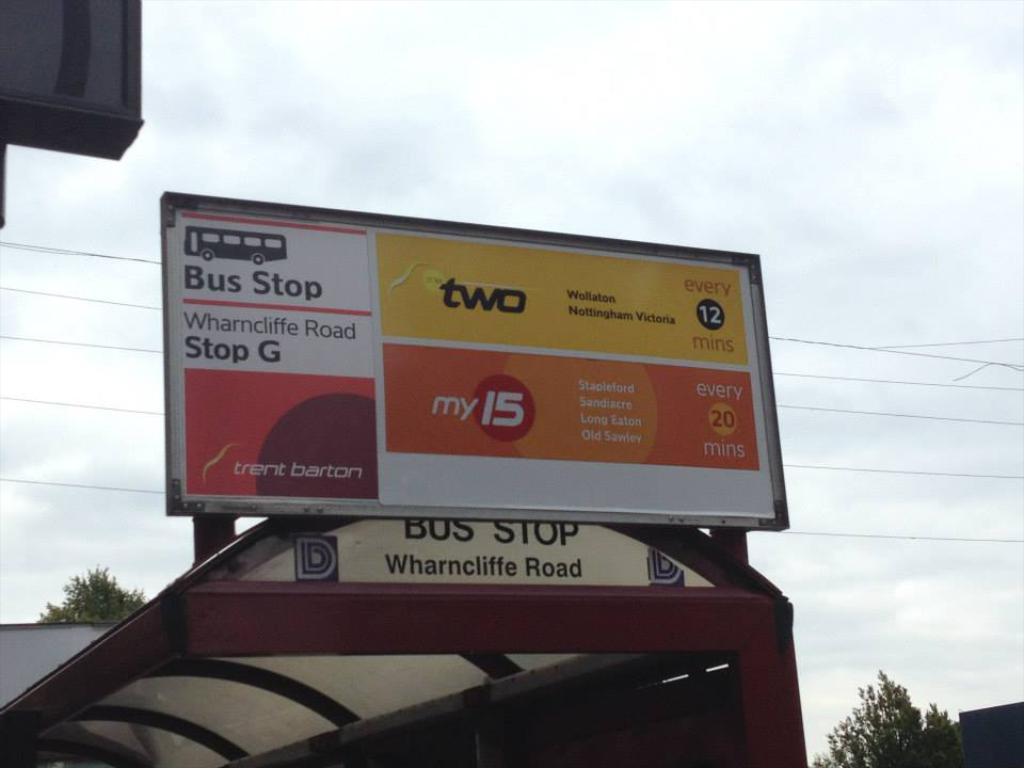<image>
Provide a brief description of the given image. A billboard hangs over the bus stop at Wharncliffe Road 